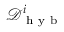Convert formula to latex. <formula><loc_0><loc_0><loc_500><loc_500>\mathcal { D } _ { h y b } ^ { i }</formula> 